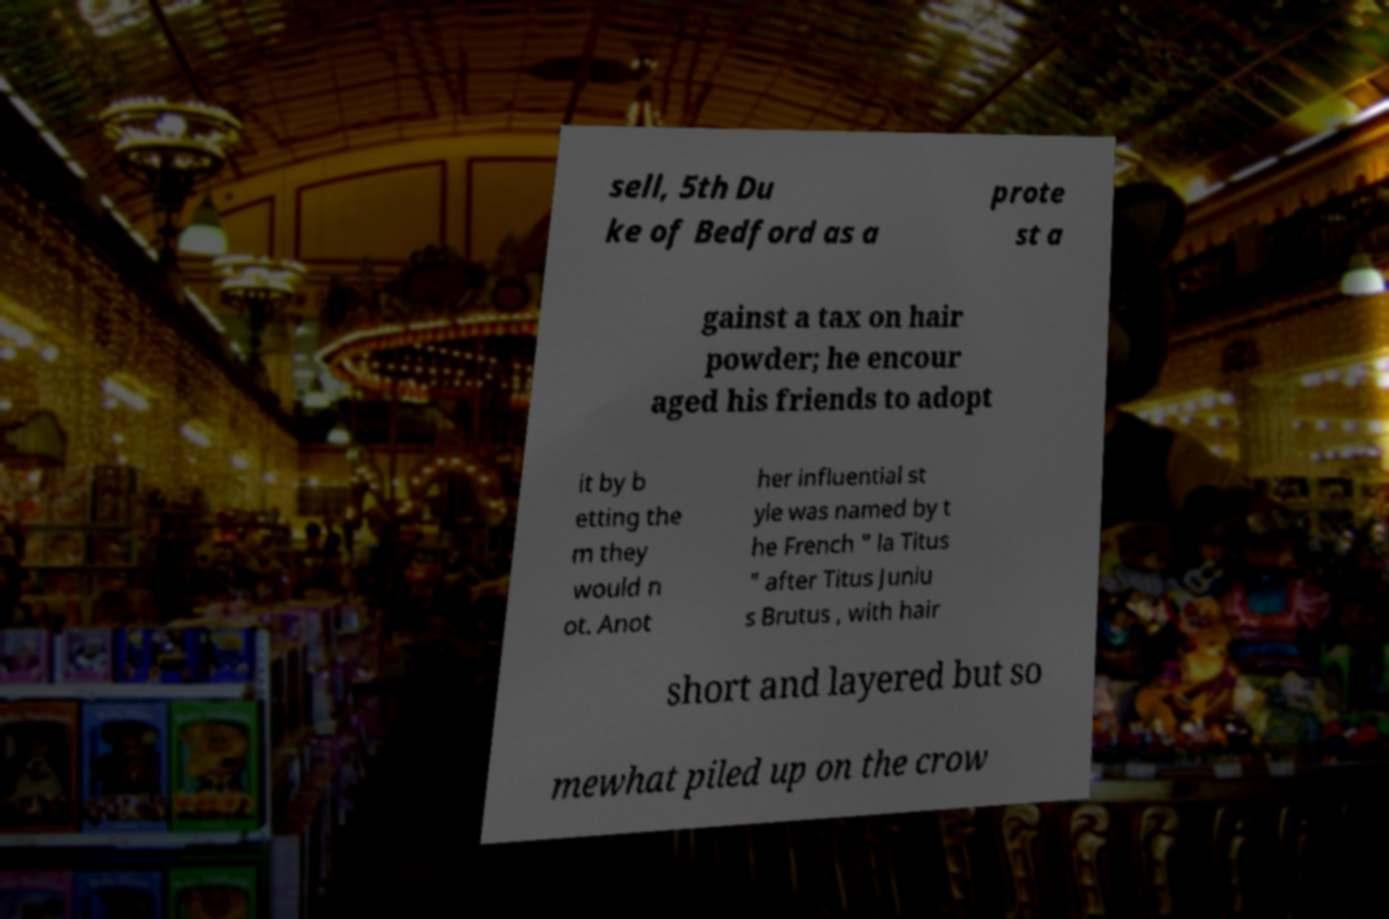Could you extract and type out the text from this image? sell, 5th Du ke of Bedford as a prote st a gainst a tax on hair powder; he encour aged his friends to adopt it by b etting the m they would n ot. Anot her influential st yle was named by t he French " la Titus " after Titus Juniu s Brutus , with hair short and layered but so mewhat piled up on the crow 